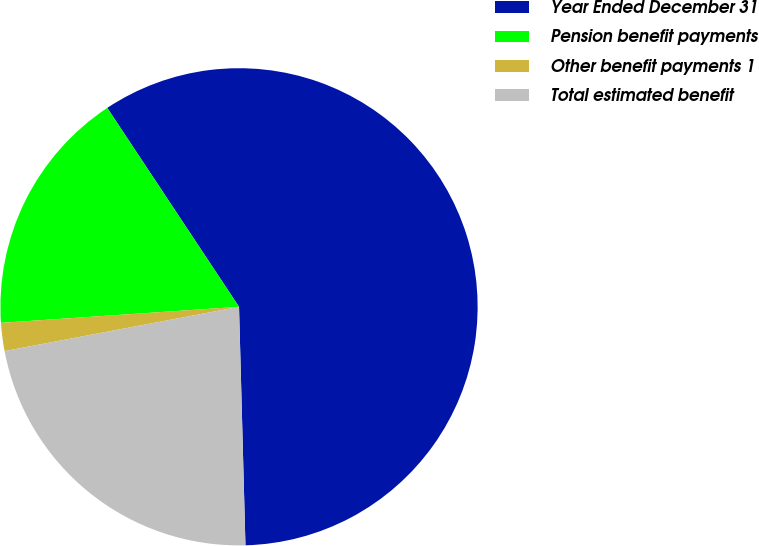Convert chart. <chart><loc_0><loc_0><loc_500><loc_500><pie_chart><fcel>Year Ended December 31<fcel>Pension benefit payments<fcel>Other benefit payments 1<fcel>Total estimated benefit<nl><fcel>58.89%<fcel>16.76%<fcel>1.9%<fcel>22.46%<nl></chart> 